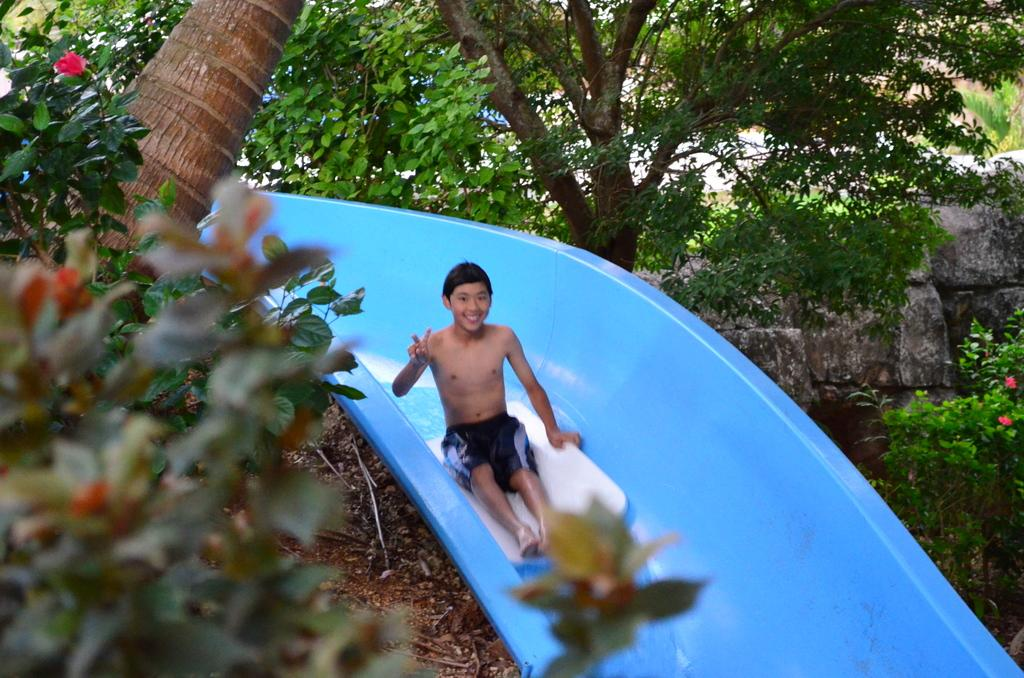Who is the main subject in the image? There is a boy in the image. How is the boy positioned in the image? The boy is coming through a plastic tube. What can be seen around the boy in the image? There are plants around the boy. What type of fly is buzzing around the boy in the image? There is no fly present in the image; it only features a boy coming through a plastic tube and plants around him. What type of umbrella is being used by the boy in the image? There is no umbrella present in the image; the boy is coming through a plastic tube and is surrounded by plants. 